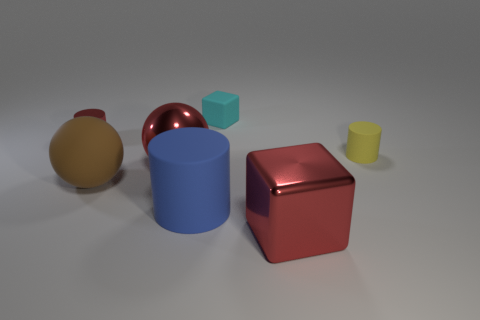Add 3 brown matte balls. How many objects exist? 10 Subtract all spheres. How many objects are left? 5 Subtract 0 green cubes. How many objects are left? 7 Subtract all red metal spheres. Subtract all green rubber balls. How many objects are left? 6 Add 4 blue matte cylinders. How many blue matte cylinders are left? 5 Add 7 big red objects. How many big red objects exist? 9 